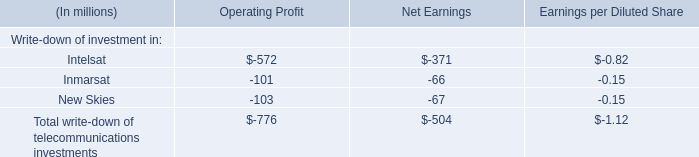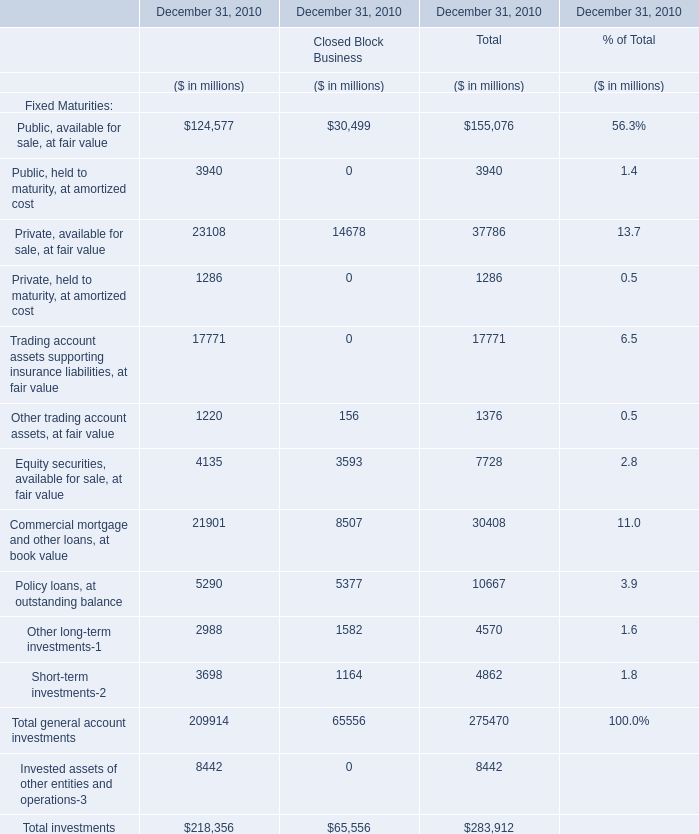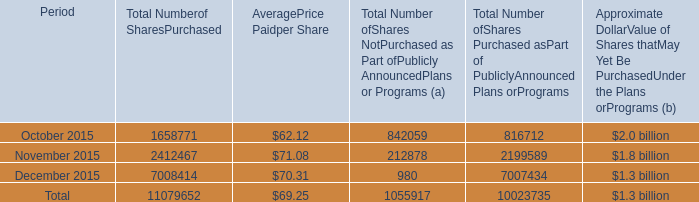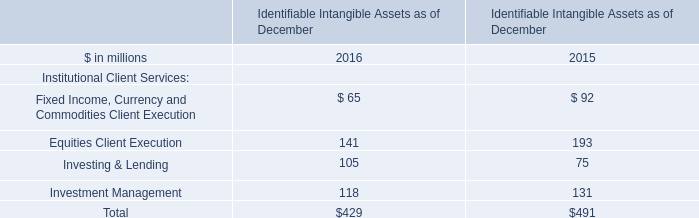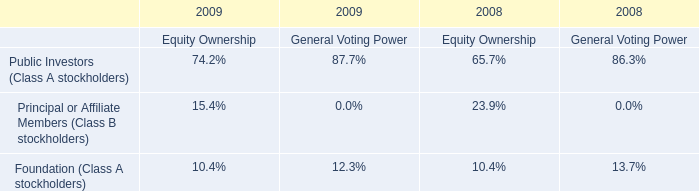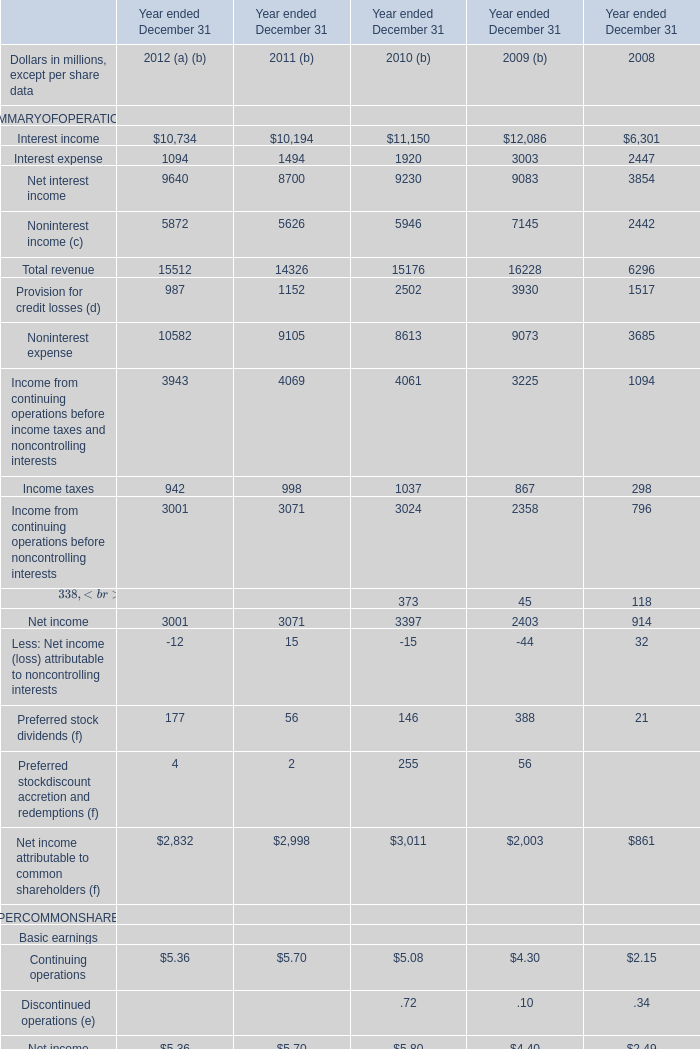What was the total amount of Closed Block Business in the range of 1000 and 2000 in 2010 for December 31, 2010? (in million) 
Computations: (1582 + 1164)
Answer: 2746.0. 